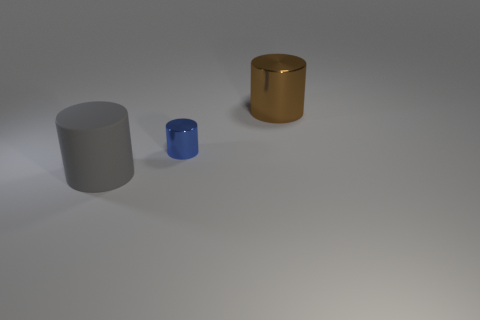How many tiny things are either blue cylinders or yellow cylinders?
Offer a terse response. 1. What size is the cylinder that is behind the metallic cylinder in front of the big thing on the right side of the rubber cylinder?
Your answer should be compact. Large. How many blue metallic cylinders are the same size as the brown object?
Offer a terse response. 0. How many things are either brown cylinders or objects in front of the brown cylinder?
Your answer should be very brief. 3. Is the rubber thing the same color as the tiny metal cylinder?
Provide a short and direct response. No. There is a metallic thing that is the same size as the rubber cylinder; what is its color?
Your answer should be very brief. Brown. How many cyan objects are matte things or big cylinders?
Offer a terse response. 0. Is the number of shiny things greater than the number of tiny shiny cylinders?
Your answer should be very brief. Yes. There is a cylinder to the right of the blue thing; is it the same size as the metal cylinder that is in front of the big metal object?
Make the answer very short. No. There is a big cylinder behind the big rubber cylinder to the left of the big object behind the big gray object; what color is it?
Give a very brief answer. Brown. 